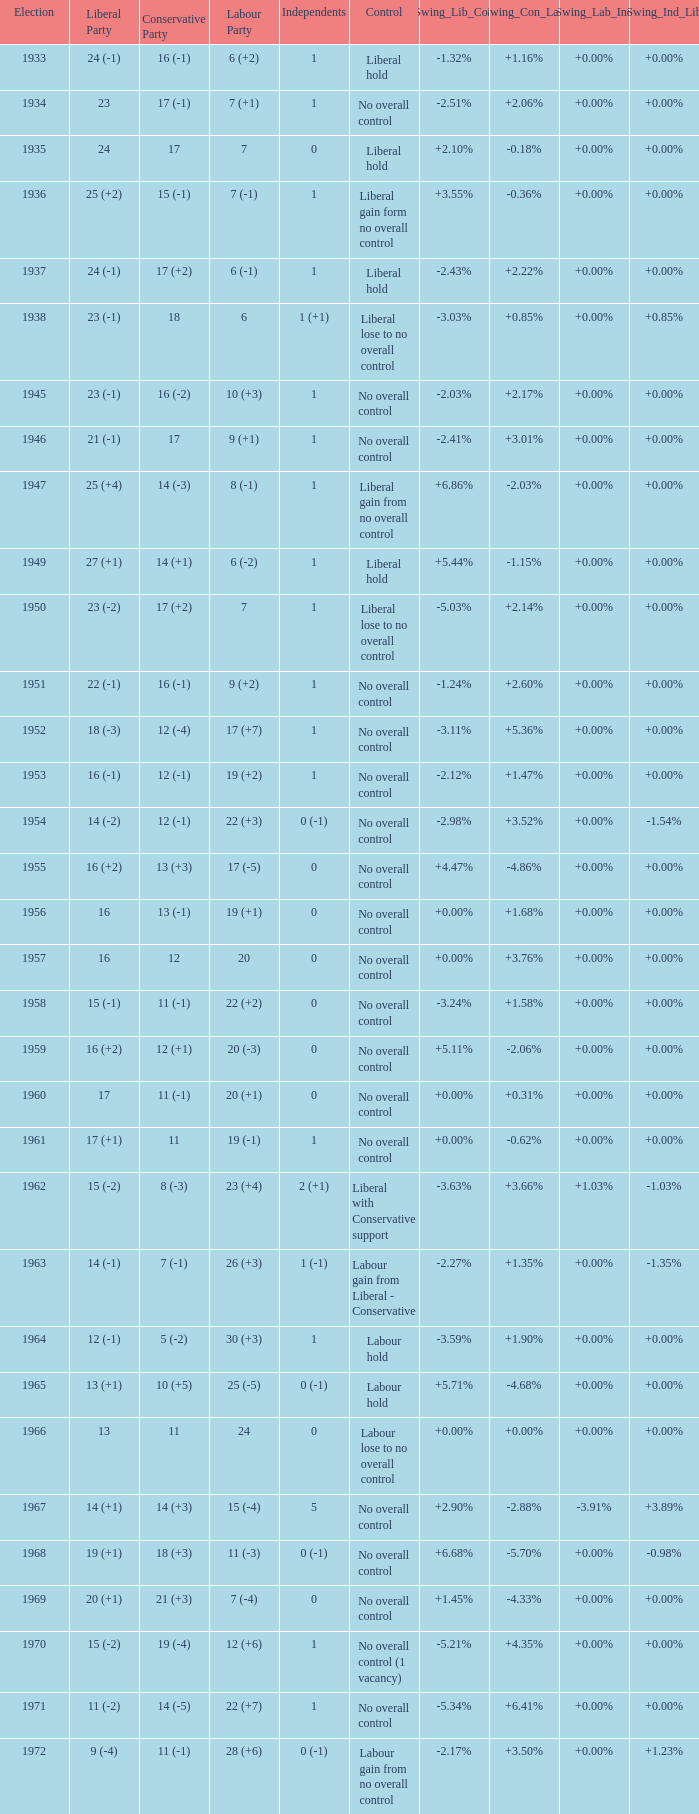What was the Liberal Party result from the election having a Conservative Party result of 16 (-1) and Labour of 6 (+2)? 24 (-1). 